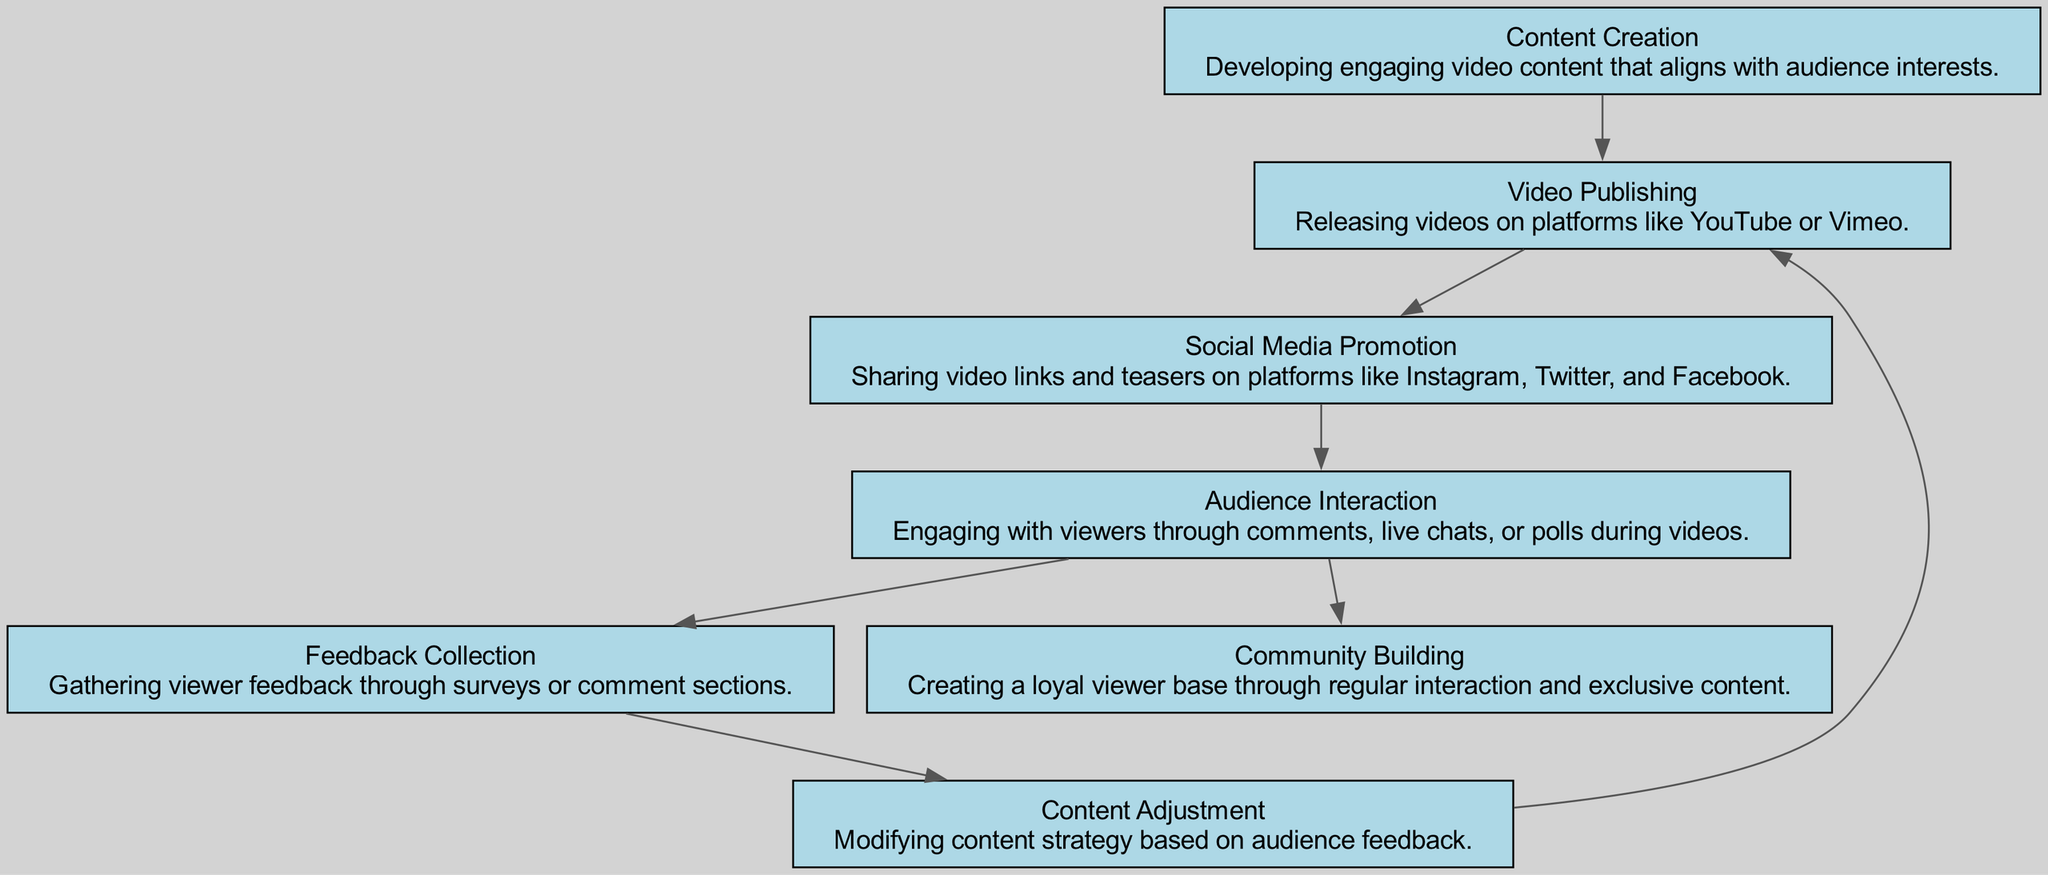What is the first step in the audience engagement journey? The diagram indicates that "Content Creation" precedes all other nodes, making it the first step in the journey.
Answer: Content Creation How many nodes are present in the diagram? Counting all unique elements in the diagram, there are a total of seven distinct nodes.
Answer: 7 What does "Video Publishing" lead to? The diagram shows that "Video Publishing" connects directly to "Social Media Promotion", indicating that it leads to this step in the audience engagement journey.
Answer: Social Media Promotion What is the purpose of "Feedback Collection"? The description provided in the node states that "Feedback Collection" involves gathering viewer feedback through surveys or comments, making its purpose clear.
Answer: Gathering viewer feedback Which nodes are linked to "Audience Interaction"? Analyzing the edges connected to "Audience Interaction", there are two outbound connections leading to "Feedback Collection" and "Community Building".
Answer: Feedback Collection, Community Building What is the last node in the audience engagement journey? Following the connections in the directed graph, it can be determined that "Community Building" is a terminal node without any outgoing edges.
Answer: Community Building Which stage involves modifying content strategy? The diagram specifies that "Content Adjustment" is the stage focused on modifying content strategy, directly following "Feedback Collection".
Answer: Content Adjustment What connects "Feedback Collection" back to "Video Publishing"? The directed connection from "Content Adjustment" points back to "Video Publishing", showing that feedback results in adjustments that circle back to the publishing stage.
Answer: Video Publishing 